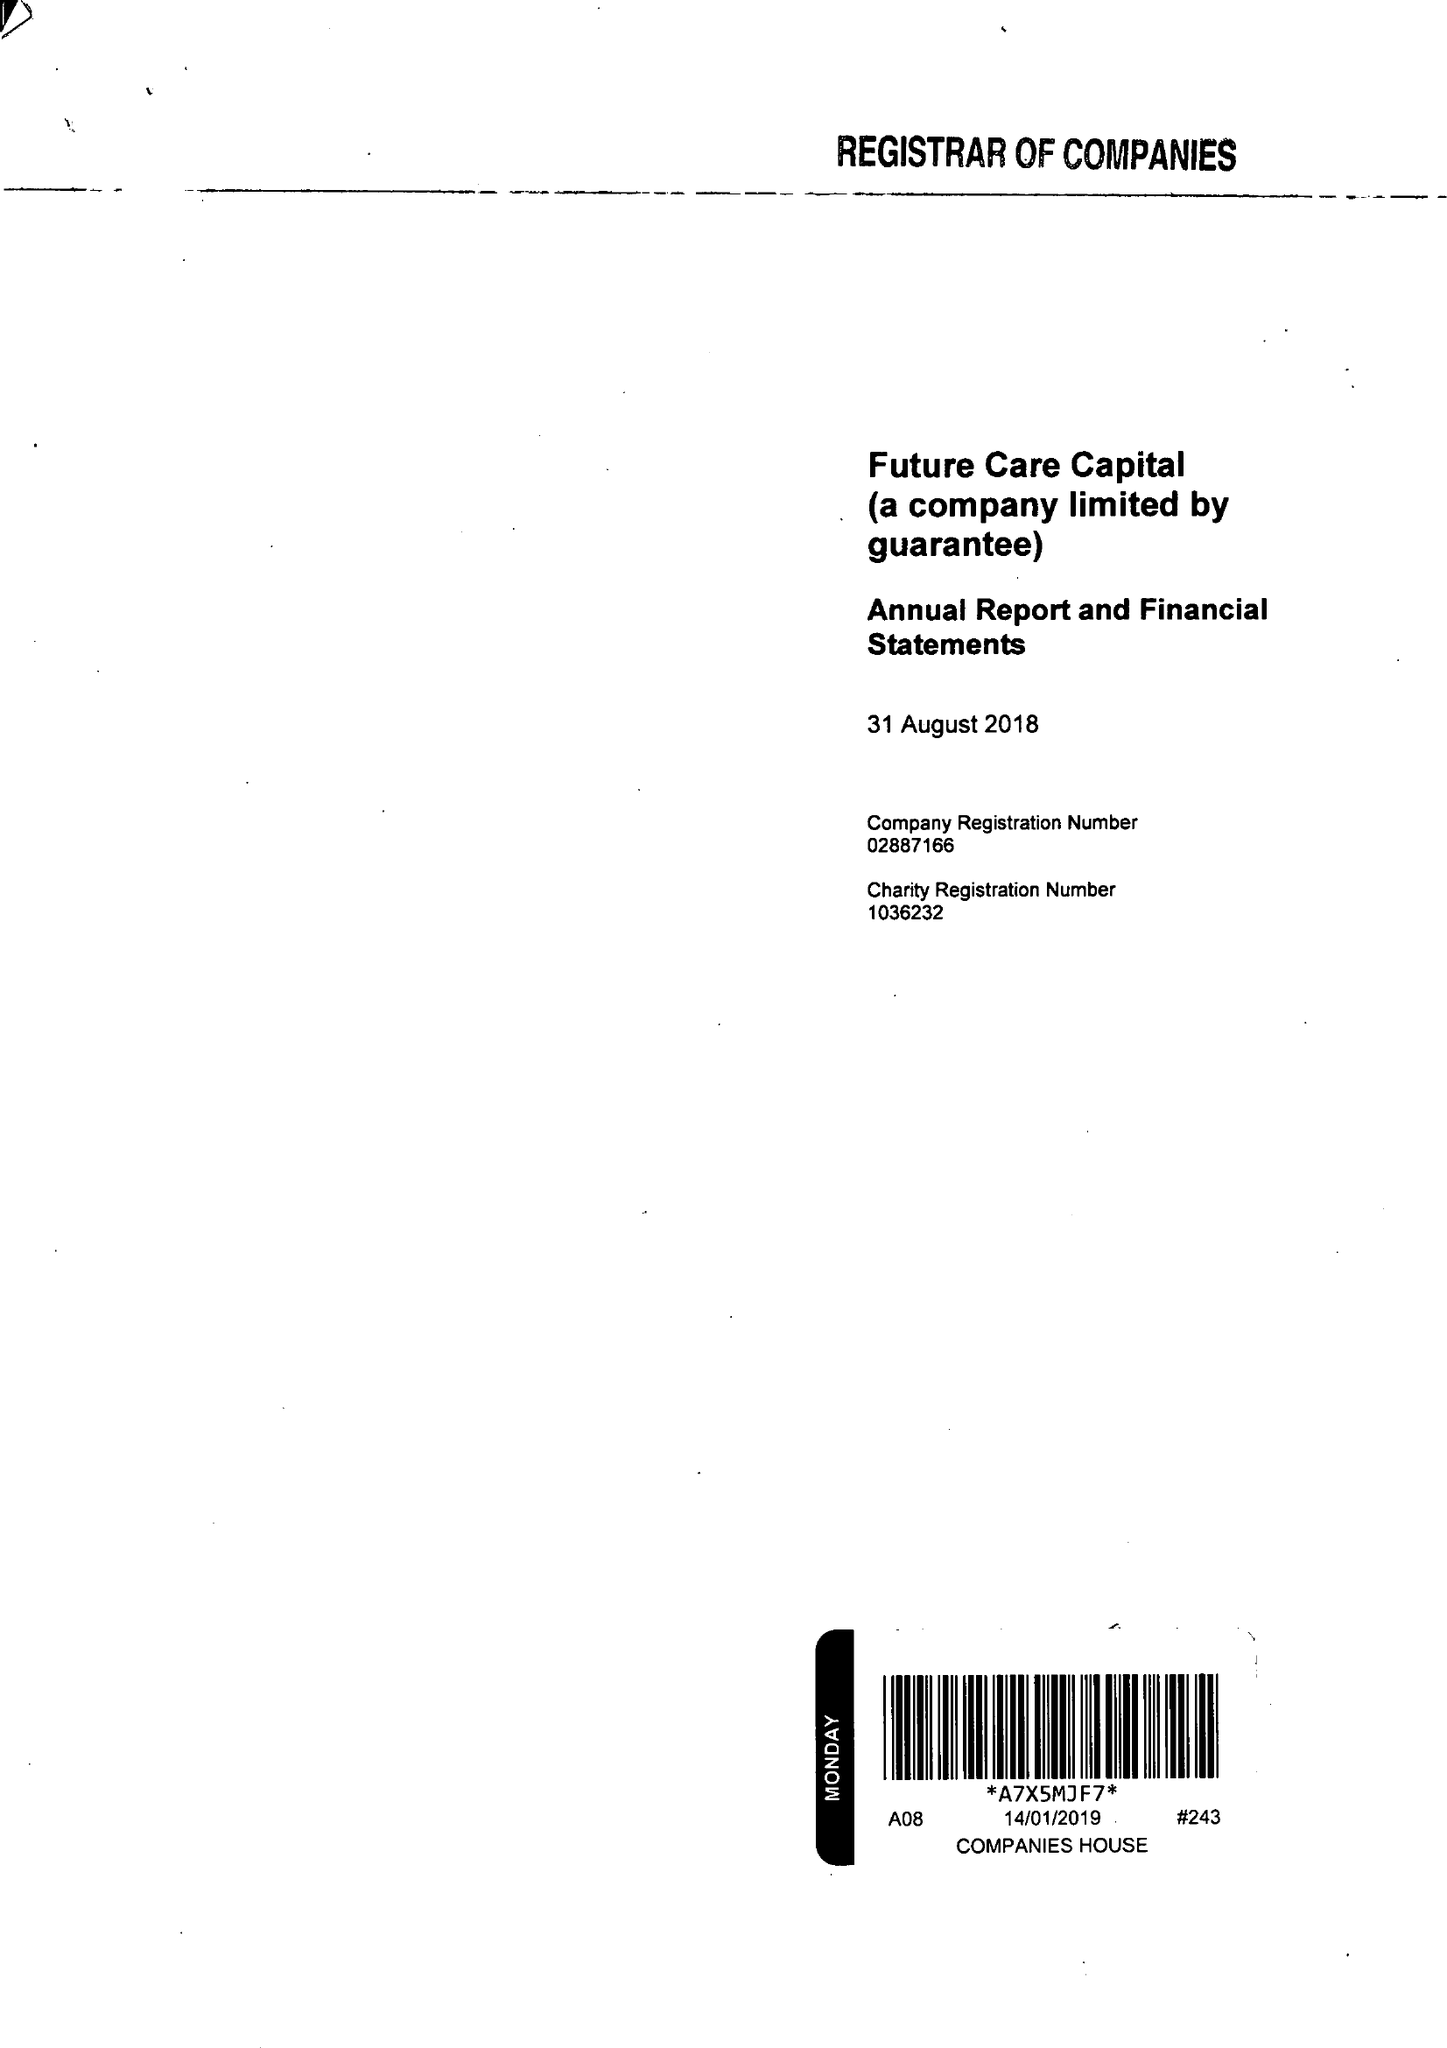What is the value for the report_date?
Answer the question using a single word or phrase. 2018-08-31 